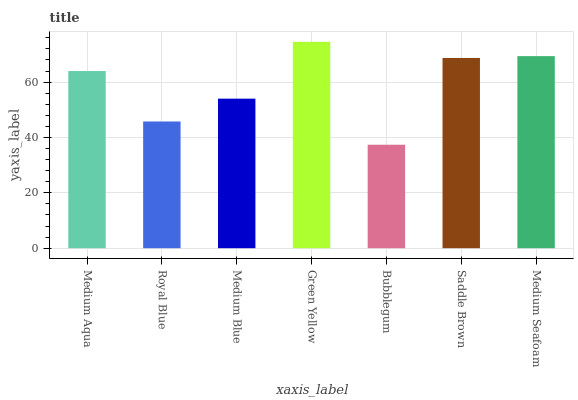Is Bubblegum the minimum?
Answer yes or no. Yes. Is Green Yellow the maximum?
Answer yes or no. Yes. Is Royal Blue the minimum?
Answer yes or no. No. Is Royal Blue the maximum?
Answer yes or no. No. Is Medium Aqua greater than Royal Blue?
Answer yes or no. Yes. Is Royal Blue less than Medium Aqua?
Answer yes or no. Yes. Is Royal Blue greater than Medium Aqua?
Answer yes or no. No. Is Medium Aqua less than Royal Blue?
Answer yes or no. No. Is Medium Aqua the high median?
Answer yes or no. Yes. Is Medium Aqua the low median?
Answer yes or no. Yes. Is Bubblegum the high median?
Answer yes or no. No. Is Medium Seafoam the low median?
Answer yes or no. No. 